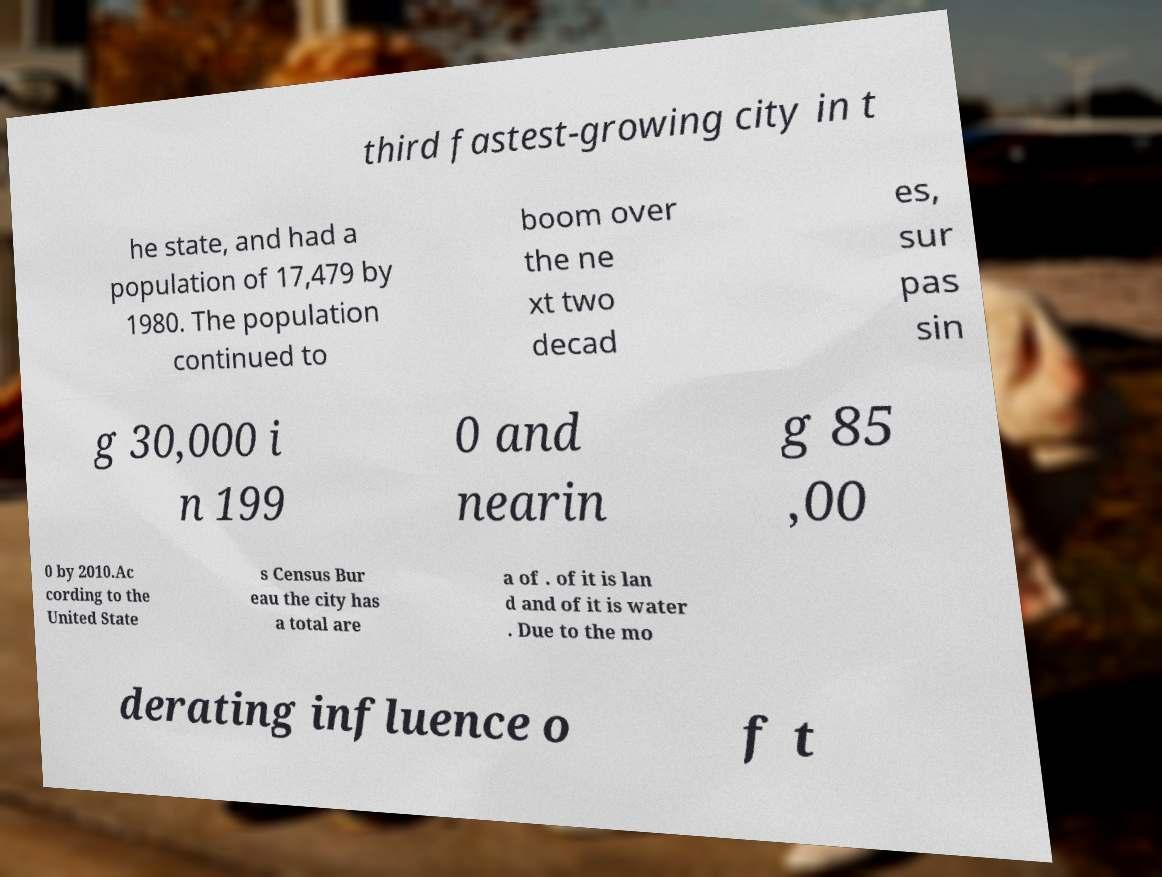What messages or text are displayed in this image? I need them in a readable, typed format. third fastest-growing city in t he state, and had a population of 17,479 by 1980. The population continued to boom over the ne xt two decad es, sur pas sin g 30,000 i n 199 0 and nearin g 85 ,00 0 by 2010.Ac cording to the United State s Census Bur eau the city has a total are a of . of it is lan d and of it is water . Due to the mo derating influence o f t 